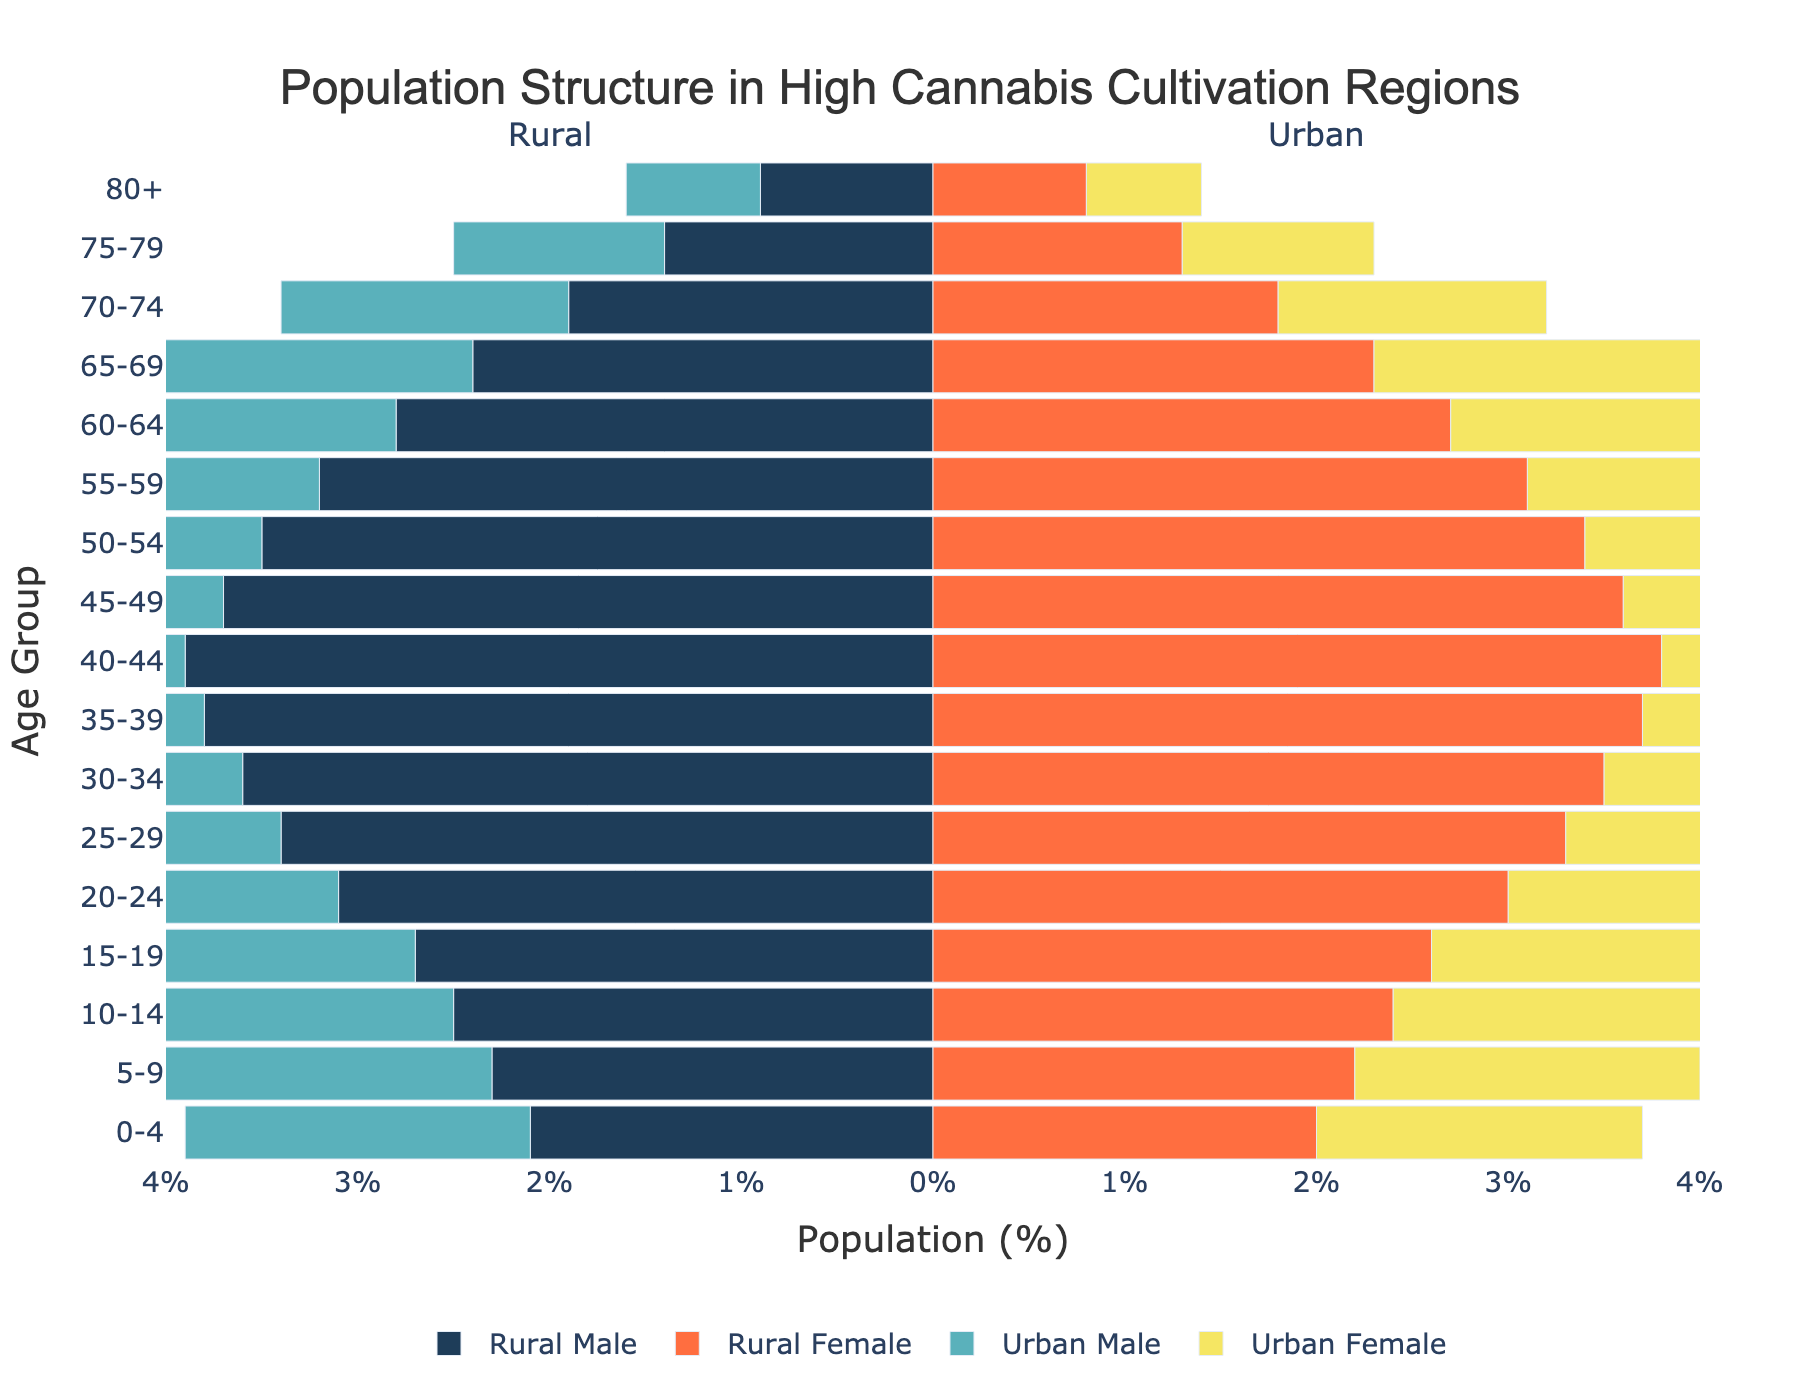What is the title of the figure? The title is located at the top of the figure and describes the overall topic being depicted. By looking at the top of the figure, the text can be read directly.
Answer: Population Structure in High Cannabis Cultivation Regions Which age group has the highest percentage in rural areas for males? By examining the lengths of the blue horizontal bars corresponding to the Rural Male category, the longest bar represents the age group with the highest percentage. This occurs for the 40-44 age group.
Answer: 40-44 Compare the rural and urban male populations in the 15-19 age group. Which is higher, and by how much? Identify the horizontal bars for the 15-19 age group under the Rural Male and Urban Male categories. The figure for Rural Male is -2.7% and for Urban Male is -2.2%. Calculate the difference: 2.7% - 2.2% = 0.5%.
Answer: Rural Male by 0.5% What is the percentage of Urban Female in the 70-74 age group? Look for the horizontal bar under the Urban Female category for the 70-74 age group. The figure shown is around 1.4%.
Answer: 1.4% What age group shows a more significant difference between Rural Male and Female populations? Identify the age group with the most considerable gap between the bars for Rural Male and Rural Female. The 40-44 age group shows the most significant difference, where Rural Male is 3.9% and Rural Female is 3.8%, making the difference 0.1%.
Answer: 40-44 Are there any age groups where the Urban Female percentage is higher than the Urban Male percentage? Compare the lengths of the horizontal bars for Urban Male and Urban Female across all age groups to identify instances where the Urban Female bar is longer. In no age group is the Urban Female percentage higher than the Urban Male percentage.
Answer: No What trend do you notice in the populations across both rural and urban areas as the age groups increase? Observe the overall pattern across age groups from 0-4 to 80+. The trend shows a gradual decrease in population percentage as the age increases in both rural and urban areas.
Answer: Decreasing trend How does the population of 60-64 year-olds in rural areas compare to the 60-64 year-olds in urban areas? Look at the horizontal bars under the 60-64 age group for both Rural and Urban categories. Rural Male is 2.8%, Rural Female is 2.7%, Urban Male is 2.4%, and Urban Female is 2.3%. The rural population is higher in this age group compared to the urban population.
Answer: Higher in rural areas What's the difference between the highest percentage of the urban male population and the rural male population? Find the highest value for Urban Male (3.4% for 35-39) and the highest value for Rural Male (3.9% for 40-44). The difference is 3.9% - 3.4% = 0.5%.
Answer: 0.5% What observation can be made about the population percentage in the 0-4 age group compared to the 80+ age group in rural areas? Compare the percentages for Rural Male and Rural Female in the 0-4 age group (2.1% and 2.0%) to the 80+ age group (0.9% and 0.8%). The younger age group has significantly higher percentages than the older age group.
Answer: 0-4 age group has higher percentages 